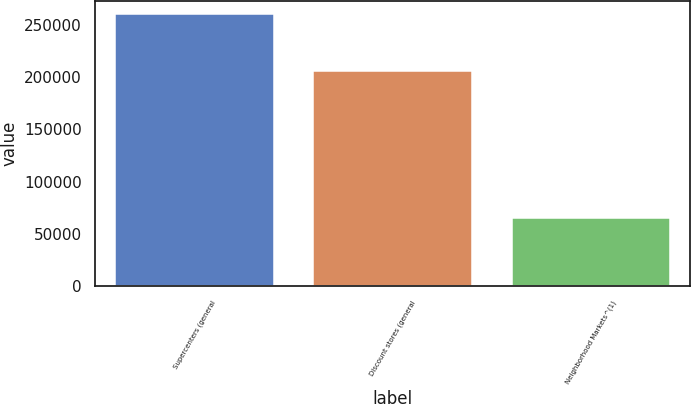Convert chart. <chart><loc_0><loc_0><loc_500><loc_500><bar_chart><fcel>Supercenters (general<fcel>Discount stores (general<fcel>Neighborhood Markets^(1)<nl><fcel>260000<fcel>206000<fcel>65000<nl></chart> 